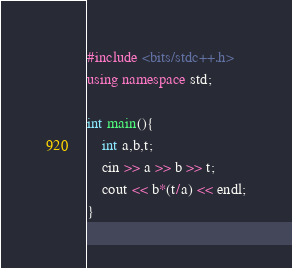Convert code to text. <code><loc_0><loc_0><loc_500><loc_500><_C++_>#include <bits/stdc++.h>
using namespace std;

int main(){
    int a,b,t;
    cin >> a >> b >> t;
    cout << b*(t/a) << endl;
}</code> 